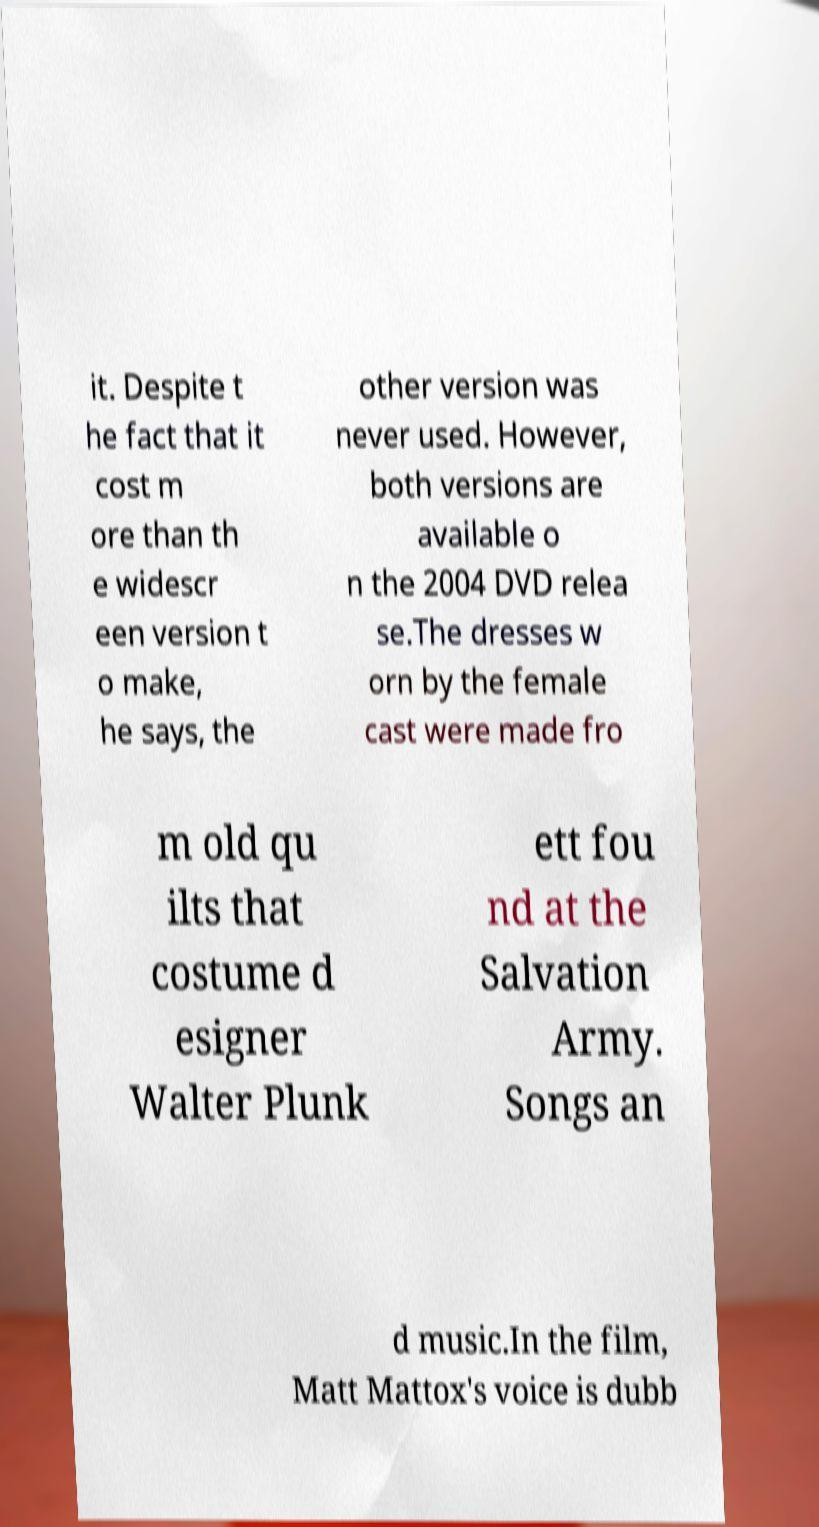Can you read and provide the text displayed in the image?This photo seems to have some interesting text. Can you extract and type it out for me? it. Despite t he fact that it cost m ore than th e widescr een version t o make, he says, the other version was never used. However, both versions are available o n the 2004 DVD relea se.The dresses w orn by the female cast were made fro m old qu ilts that costume d esigner Walter Plunk ett fou nd at the Salvation Army. Songs an d music.In the film, Matt Mattox's voice is dubb 